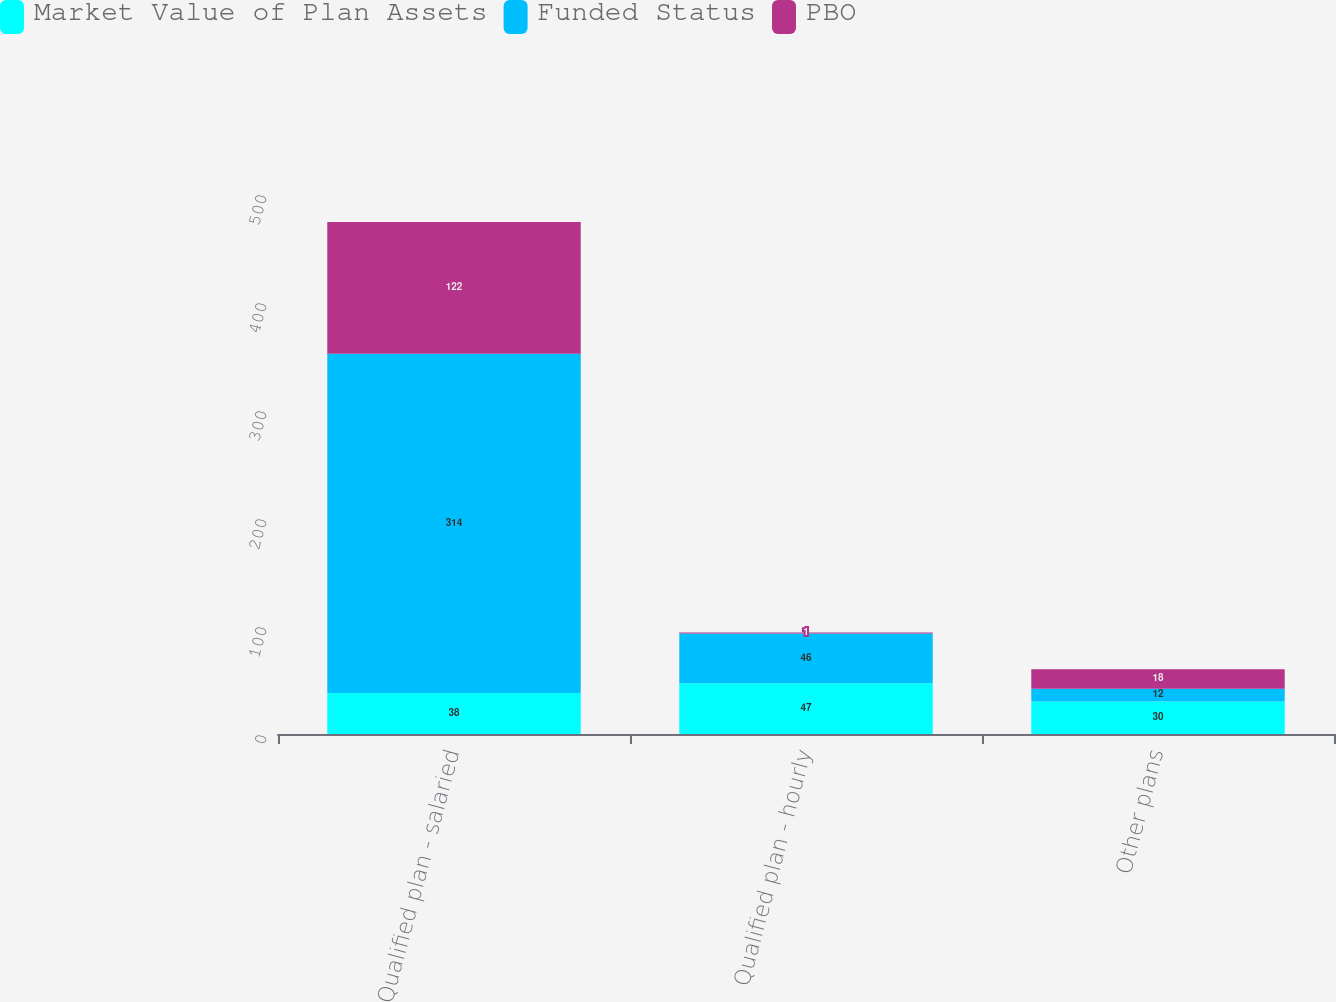Convert chart to OTSL. <chart><loc_0><loc_0><loc_500><loc_500><stacked_bar_chart><ecel><fcel>Qualified plan - salaried<fcel>Qualified plan - hourly<fcel>Other plans<nl><fcel>Market Value of Plan Assets<fcel>38<fcel>47<fcel>30<nl><fcel>Funded Status<fcel>314<fcel>46<fcel>12<nl><fcel>PBO<fcel>122<fcel>1<fcel>18<nl></chart> 